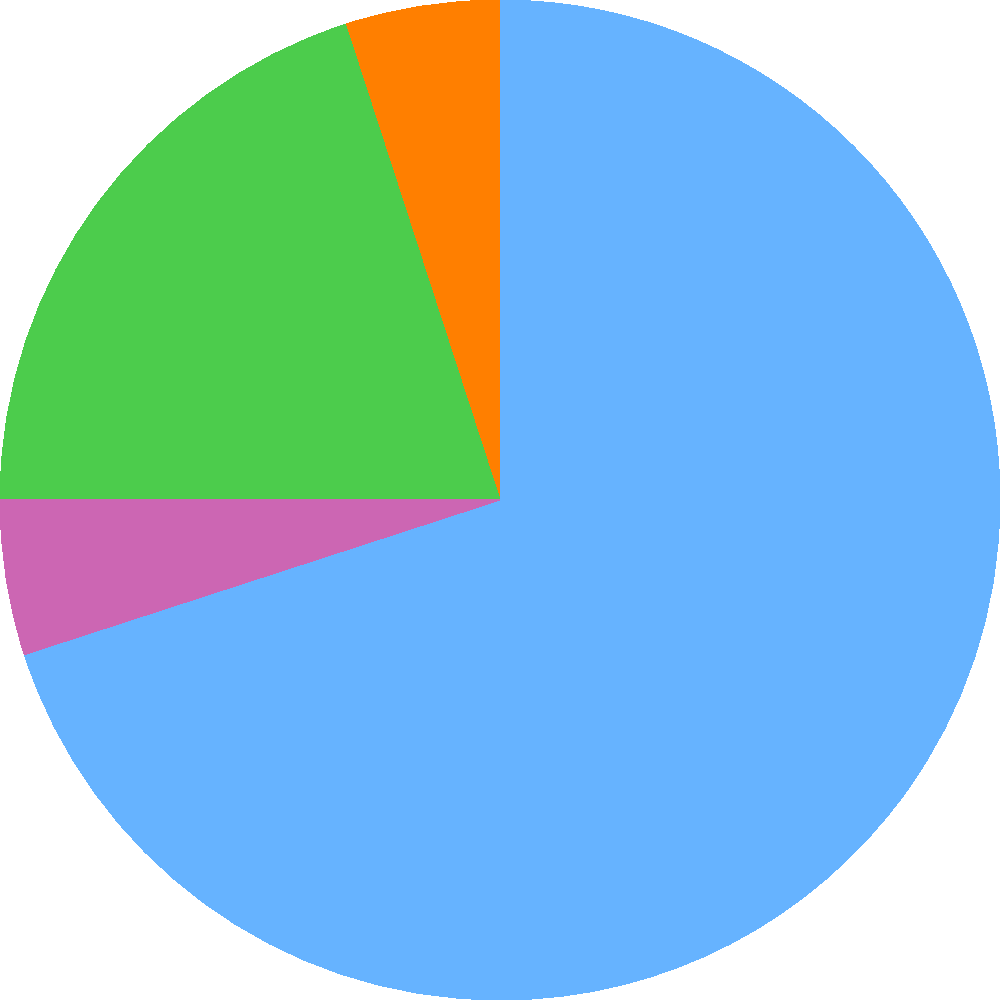Based on the pie chart showing the distribution of the marketing budget across different channels, which two channels combined account for more than half of the total budget? To determine which two channels combined account for more than half of the total budget, we need to follow these steps:

1. Identify the two largest segments in the pie chart:
   - Social Media: 30%
   - PPC (Pay-Per-Click): 25%

2. Calculate the sum of these two largest segments:
   $30\% + 25\% = 55\%$

3. Check if this sum exceeds 50% of the total budget:
   $55\% > 50\%$

4. Verify that no other combination of two channels exceeds this percentage:
   - Social Media (30%) + Email (20%) = 50%
   - Social Media (30%) + SEO (15%) = 45%
   - Social Media (30%) + Content (10%) = 40%
   - PPC (25%) + Email (20%) = 45%
   - PPC (25%) + SEO (15%) = 40%
   - PPC (25%) + Content (10%) = 35%

Therefore, Social Media and PPC are the only two channels that, when combined, account for more than half of the total marketing budget.
Answer: Social Media and PPC 